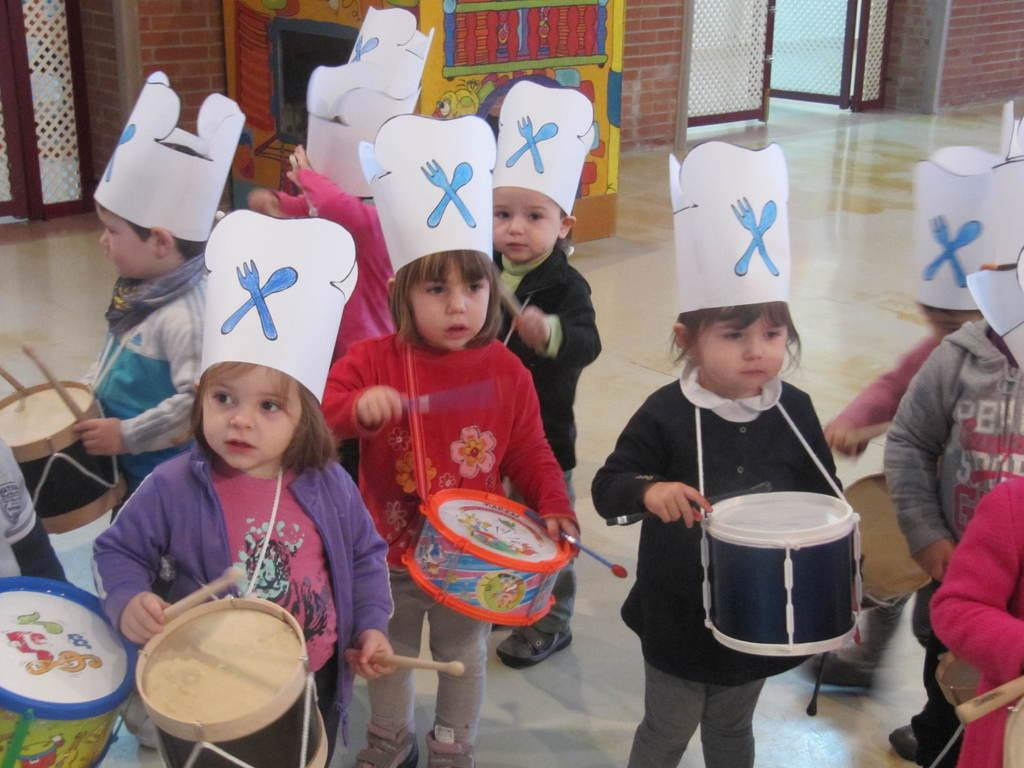What is the main subject of the image? The main subject of the image is a group of children. What are the children holding in the image? The children are holding drums in the image. What type of birds can be seen flying over the children in the image? There are no birds visible in the image; it only features a group of children holding drums. 